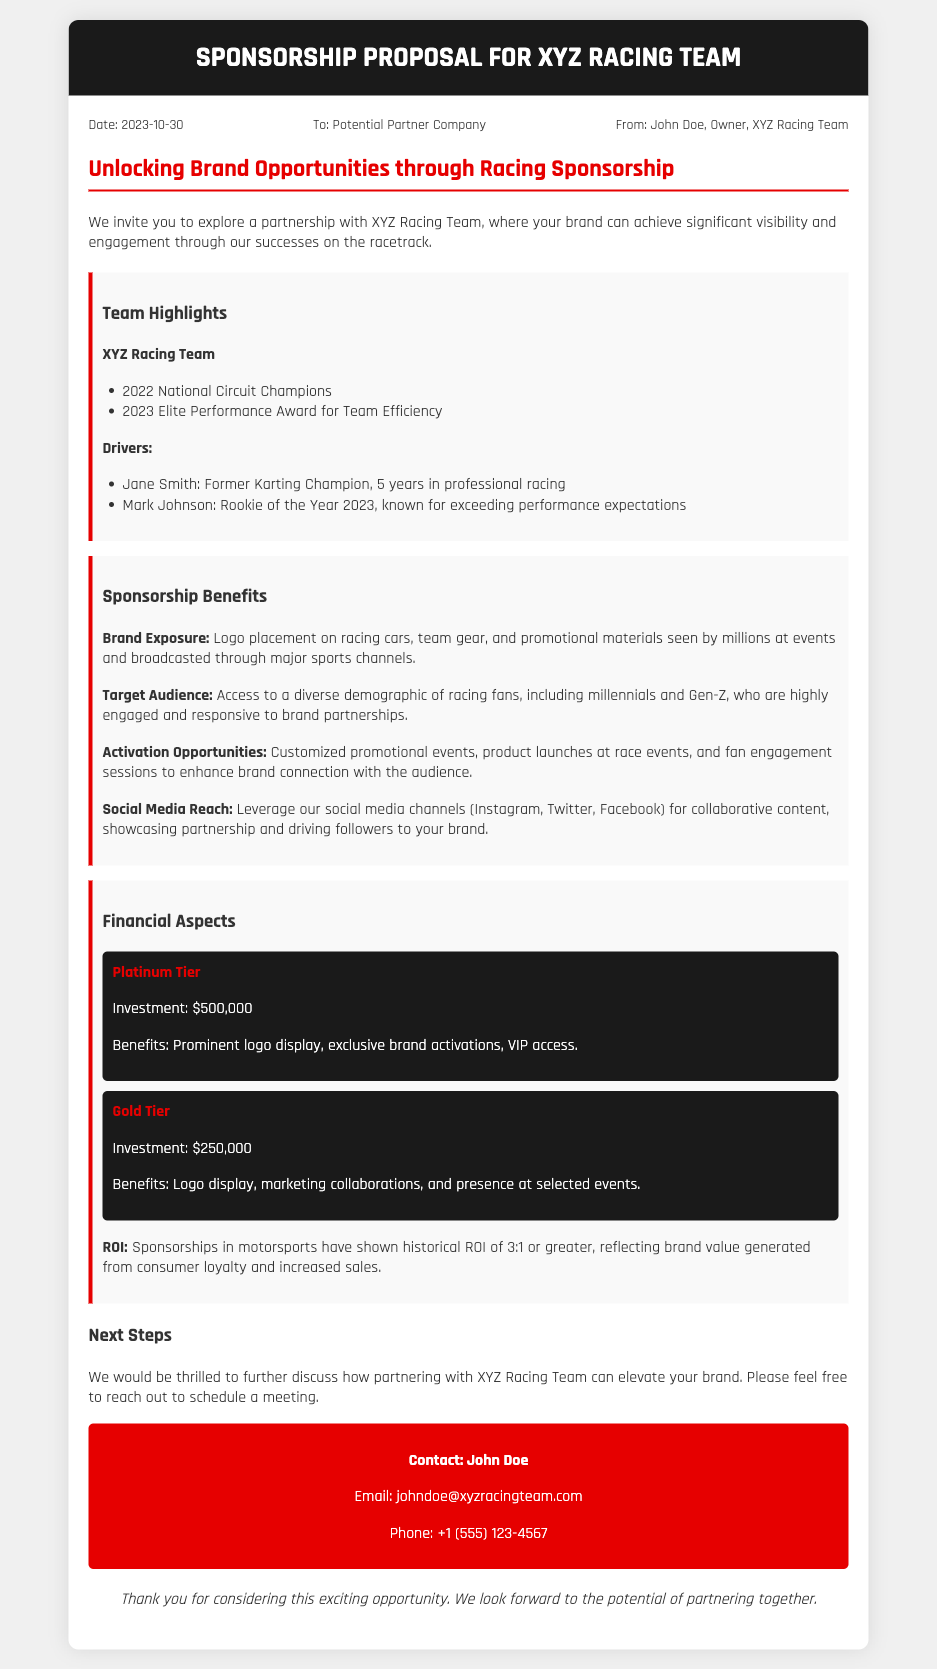What is the date of the memo? The date of the memo is stated in the meta section as 2023-10-30.
Answer: 2023-10-30 Who is the owner of the XYZ Racing Team? The owner of the XYZ Racing Team is mentioned in the meta section as John Doe.
Answer: John Doe What is the investment amount for the Platinum Tier? The investment amount is outlined in the financial aspects section, stating $500,000 for the Platinum Tier.
Answer: $500,000 Which award did the team receive in 2023? The document indicates that the team received the Elite Performance Award for Team Efficiency in 2023.
Answer: Elite Performance Award for Team Efficiency What are two benefits of sponsorship mentioned in the document? The document lists benefits such as brand exposure and activation opportunities in the sponsorship benefits section.
Answer: Brand exposure and activation opportunities What is the expected ROI for sponsorships in motorsports? The document states that historical ROI for sponsorships in motorsports typically shows a ratio of 3:1 or greater.
Answer: 3:1 What is the primary purpose of the memo? The memo's primary purpose is to propose a partnership through sponsorship with XYZ Racing Team for brand visibility.
Answer: Propose a partnership through sponsorship Which social media platforms can be leveraged for promotional content? The document mentions Instagram, Twitter, and Facebook as social media platforms for promotional content.
Answer: Instagram, Twitter, Facebook What is suggested as the next step in the sponsorship proposal? The next step suggested in the memo is to schedule a meeting to discuss the partnership further.
Answer: Schedule a meeting 